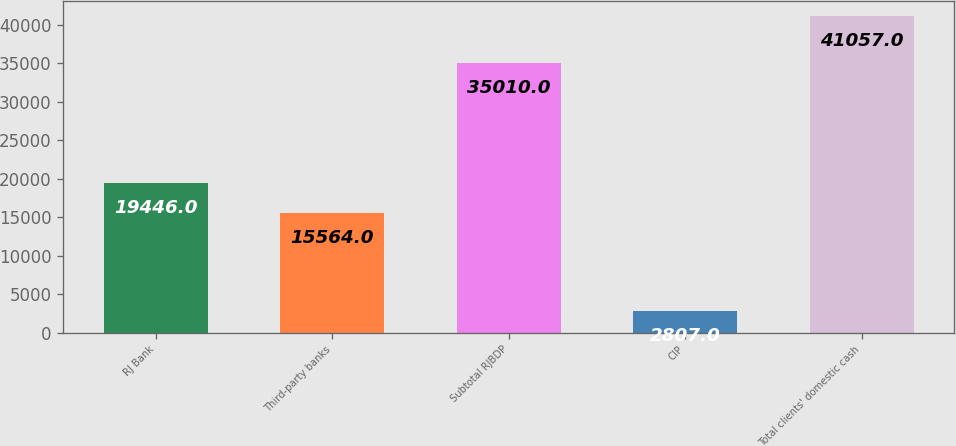Convert chart. <chart><loc_0><loc_0><loc_500><loc_500><bar_chart><fcel>RJ Bank<fcel>Third-party banks<fcel>Subtotal RJBDP<fcel>CIP<fcel>Total clients' domestic cash<nl><fcel>19446<fcel>15564<fcel>35010<fcel>2807<fcel>41057<nl></chart> 